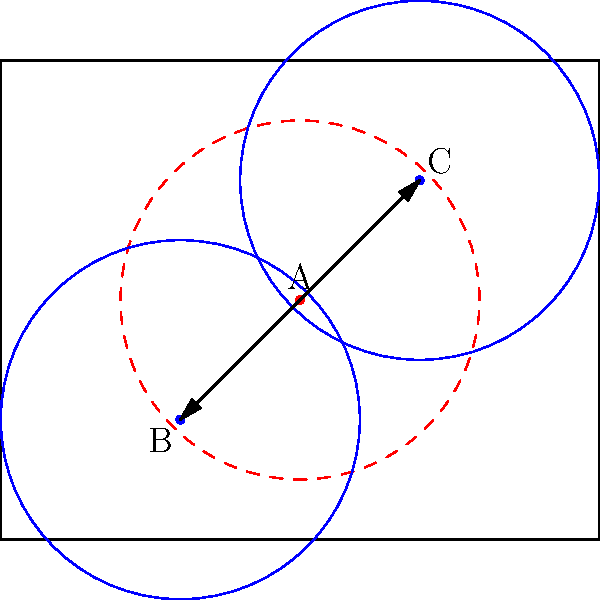In a rectangular room measuring 10m by 8m, a sprinkler head (A) is initially positioned at the center (5,4). To maximize coverage, it needs to be rotated to two new positions (B and C). If the sprinkler has a coverage radius of 3m and is rotated 45° clockwise and counterclockwise from its original position, what is the total area covered by the three sprinkler positions? Let's approach this step-by-step:

1) First, we need to find the coordinates of points B and C after rotation.
   - Point B (45° clockwise): $(5 + 2\sqrt{2}, 4 - 2\sqrt{2}) \approx (7.83, 1.17)$
   - Point C (45° counterclockwise): $(5 - 2\sqrt{2}, 4 + 2\sqrt{2}) \approx (2.17, 6.83)$

2) The area covered by each sprinkler is a circle with radius 3m.
   Area of one circle = $\pi r^2 = \pi (3)^2 = 9\pi$ m²

3) To find the total area, we need to calculate the union of these three circles.

4) The exact calculation of this union is complex due to the overlapping areas. However, we can estimate it using the following method:
   - Total area ≈ (Area of 3 circles) - (Area of 2 circle overlaps)

5) The overlap between two circles can be approximated as a lens shape. The area of this lens can be calculated using the formula:
   $A_{lens} = 2r^2 \arccos(\frac{d}{2r}) - d\sqrt{r^2 - \frac{d^2}{4}}$
   where $r$ is the radius and $d$ is the distance between circle centers.

6) The distance between circle centers is $2\sqrt{2} \approx 2.83$ m.

7) Plugging into the lens area formula:
   $A_{lens} = 2(3^2) \arccos(\frac{2.83}{2(3)}) - 2.83\sqrt{3^2 - \frac{2.83^2}{4}} \approx 6.59$ m²

8) Therefore, the estimated total area is:
   Total Area ≈ $(3 * 9\pi) - (3 * 6.59) \approx 65.19$ m²
Answer: Approximately 65.19 m² 